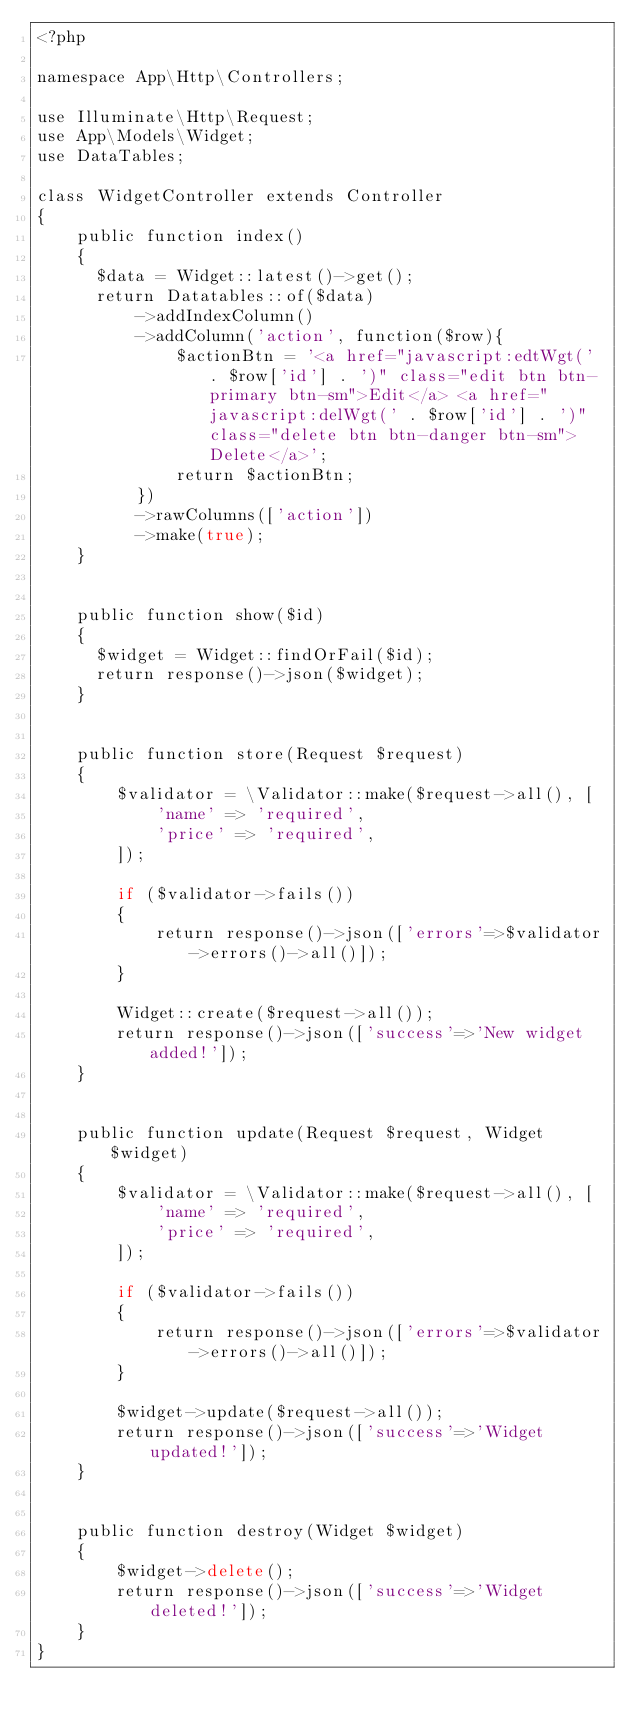Convert code to text. <code><loc_0><loc_0><loc_500><loc_500><_PHP_><?php

namespace App\Http\Controllers;

use Illuminate\Http\Request;
use App\Models\Widget;
use DataTables;

class WidgetController extends Controller
{
    public function index()
    {
      $data = Widget::latest()->get();
      return Datatables::of($data)
          ->addIndexColumn()
          ->addColumn('action', function($row){
              $actionBtn = '<a href="javascript:edtWgt(' . $row['id'] . ')" class="edit btn btn-primary btn-sm">Edit</a> <a href="javascript:delWgt(' . $row['id'] . ')" class="delete btn btn-danger btn-sm">Delete</a>';
              return $actionBtn;
          })
          ->rawColumns(['action'])
          ->make(true);
    }


    public function show($id)
    {
      $widget = Widget::findOrFail($id);
      return response()->json($widget);
    }


    public function store(Request $request)
    {
        $validator = \Validator::make($request->all(), [
            'name' => 'required',
            'price' => 'required',
        ]);

        if ($validator->fails())
        {
            return response()->json(['errors'=>$validator->errors()->all()]);
        }

        Widget::create($request->all());
        return response()->json(['success'=>'New widget added!']);
    }


    public function update(Request $request, Widget $widget)
    {
        $validator = \Validator::make($request->all(), [
            'name' => 'required',
            'price' => 'required',
        ]);

        if ($validator->fails())
        {
            return response()->json(['errors'=>$validator->errors()->all()]);
        }

        $widget->update($request->all());
        return response()->json(['success'=>'Widget updated!']);
    }


    public function destroy(Widget $widget)
    {
        $widget->delete();
        return response()->json(['success'=>'Widget deleted!']);
    }
}
</code> 